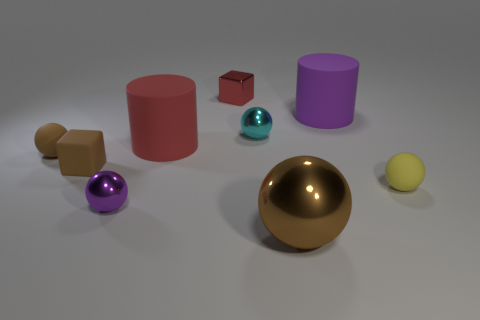How many small brown things are in front of the large red thing?
Your answer should be very brief. 2. How many other things are there of the same color as the metal cube?
Give a very brief answer. 1. Are there fewer yellow things behind the tiny brown block than cubes that are on the right side of the small purple shiny object?
Give a very brief answer. Yes. What number of things are either small rubber things that are behind the yellow thing or small objects?
Offer a terse response. 6. Is the size of the cyan metallic ball the same as the rubber ball to the left of the small cyan metallic object?
Give a very brief answer. Yes. What is the size of the purple thing that is the same shape as the large brown thing?
Ensure brevity in your answer.  Small. There is a big object that is in front of the matte sphere to the left of the yellow sphere; what number of tiny cyan objects are behind it?
Give a very brief answer. 1. What number of balls are brown things or tiny brown objects?
Give a very brief answer. 2. The rubber cube that is on the left side of the rubber sphere on the right side of the small matte ball behind the brown block is what color?
Offer a very short reply. Brown. What number of other things are there of the same size as the purple rubber cylinder?
Your response must be concise. 2. 